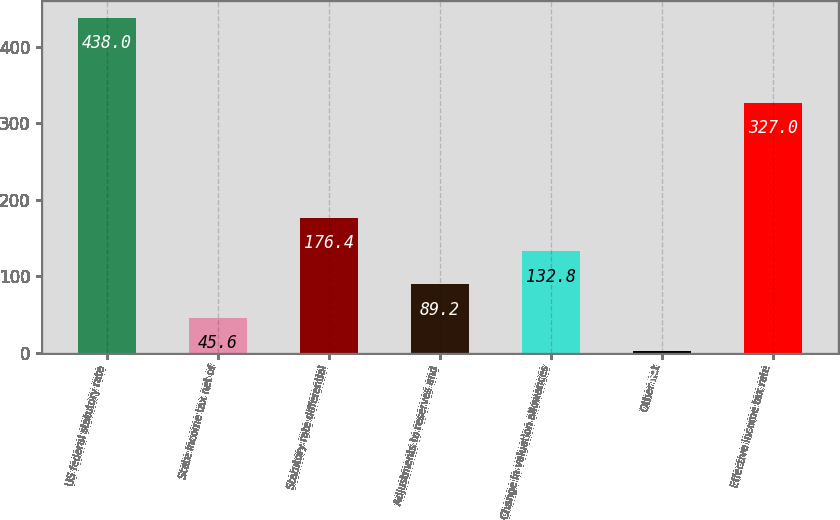Convert chart. <chart><loc_0><loc_0><loc_500><loc_500><bar_chart><fcel>US federal statutory rate<fcel>State income tax net of<fcel>Statutory rate differential<fcel>Adjustments to reserves and<fcel>Change in valuation allowances<fcel>Other net<fcel>Effective income tax rate<nl><fcel>438<fcel>45.6<fcel>176.4<fcel>89.2<fcel>132.8<fcel>2<fcel>327<nl></chart> 